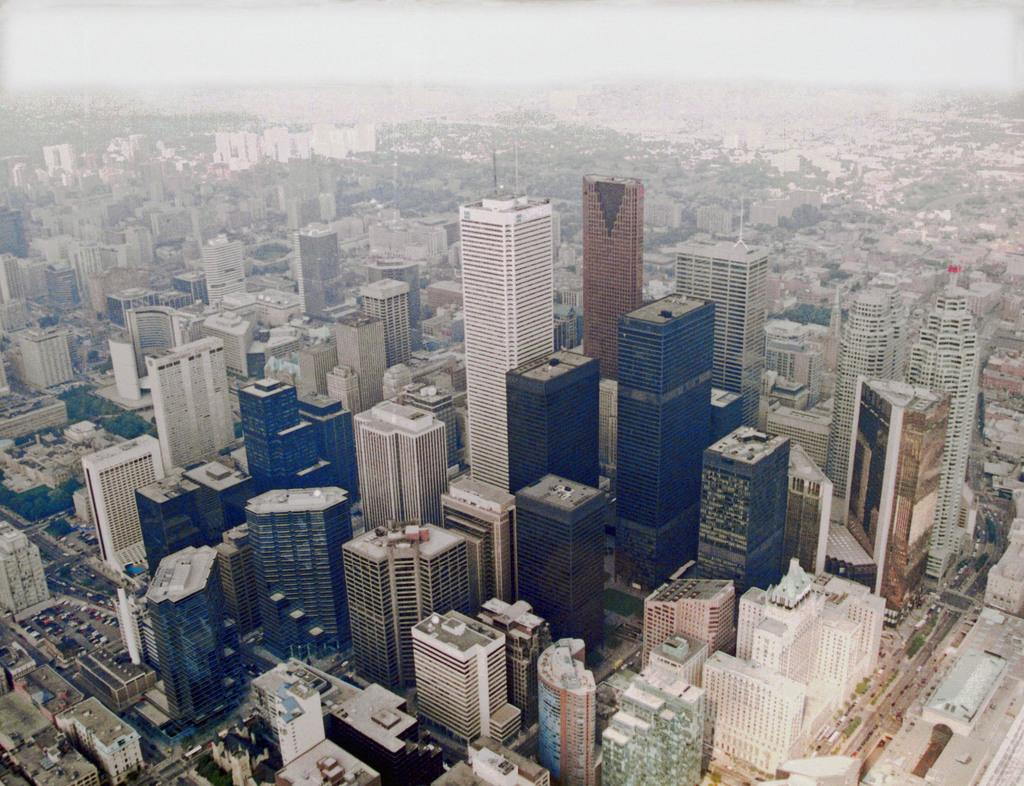What type of structures can be seen in the image? There is a group of buildings in the image. What else is visible besides the buildings? Vehicles, roads, trees, and the sky are visible in the image. Can you describe the roads in the image? Roads are visible in the image. What is the condition of the sky in the image? The sky is visible at the top of the image. Where is the button located in the image? There is no button present in the image. What type of place is depicted in the image? The image does not depict a specific place; it shows a group of buildings, vehicles, roads, trees, and the sky. 